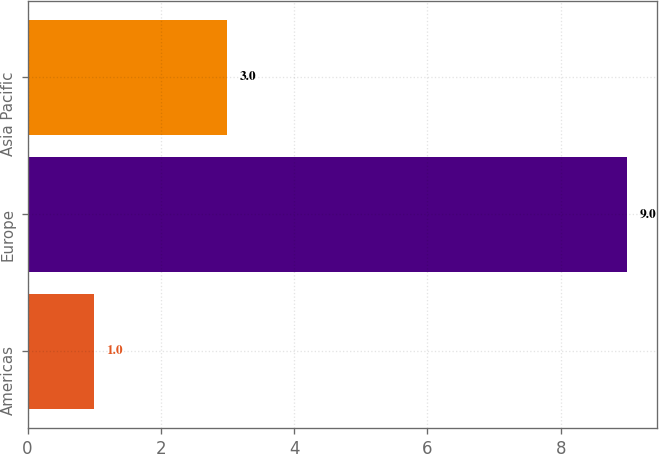Convert chart to OTSL. <chart><loc_0><loc_0><loc_500><loc_500><bar_chart><fcel>Americas<fcel>Europe<fcel>Asia Pacific<nl><fcel>1<fcel>9<fcel>3<nl></chart> 